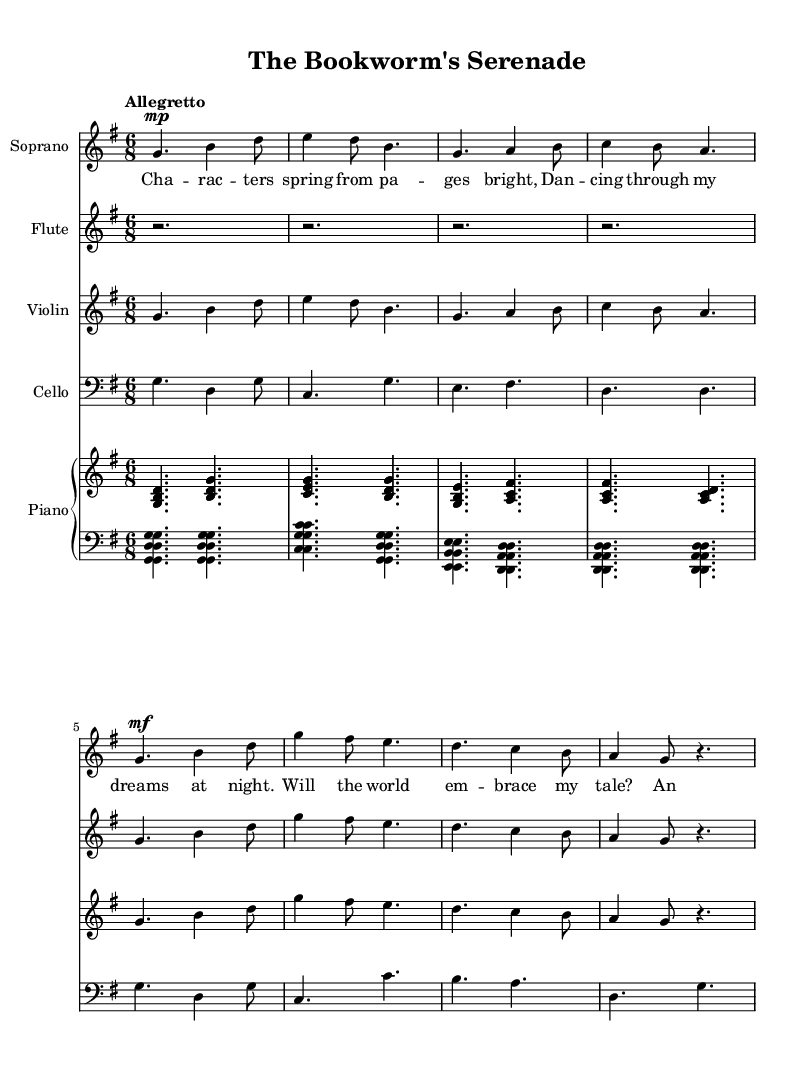What is the key signature of this music? The key signature is indicated at the beginning of the score, which shows one sharp. This puts the piece in G major.
Answer: G major What is the time signature of this music? The time signature is located at the beginning of the score, represented as "6/8," which means there are six eighth notes in a measure.
Answer: 6/8 What is the tempo marking given for this piece? The tempo marking is placed at the beginning of the score and indicates "Allegretto," suggesting a moderately fast pace.
Answer: Allegretto How many measures are there in the soprano part? By counting the measure bars in the soprano part, we see there are a total of eight measures presented.
Answer: Eight What is the dynamic marking for the first phrase of the soprano? The dynamic marking for the first phrase of the soprano is indicated as "mp," which stands for mezzo-piano, meaning moderately soft.
Answer: Mezzo-piano What specific type of operatic form is utilized in this piece? The piece uses a whimsical operetta form, characterized by its light and humorous style, often featuring characters from literature.
Answer: Operetta Which instruments are featured in this score? A quick glance at the instrumentation at the beginning reveals that the score includes Soprano, Flute, Violin, Cello, and Piano.
Answer: Soprano, Flute, Violin, Cello, Piano 